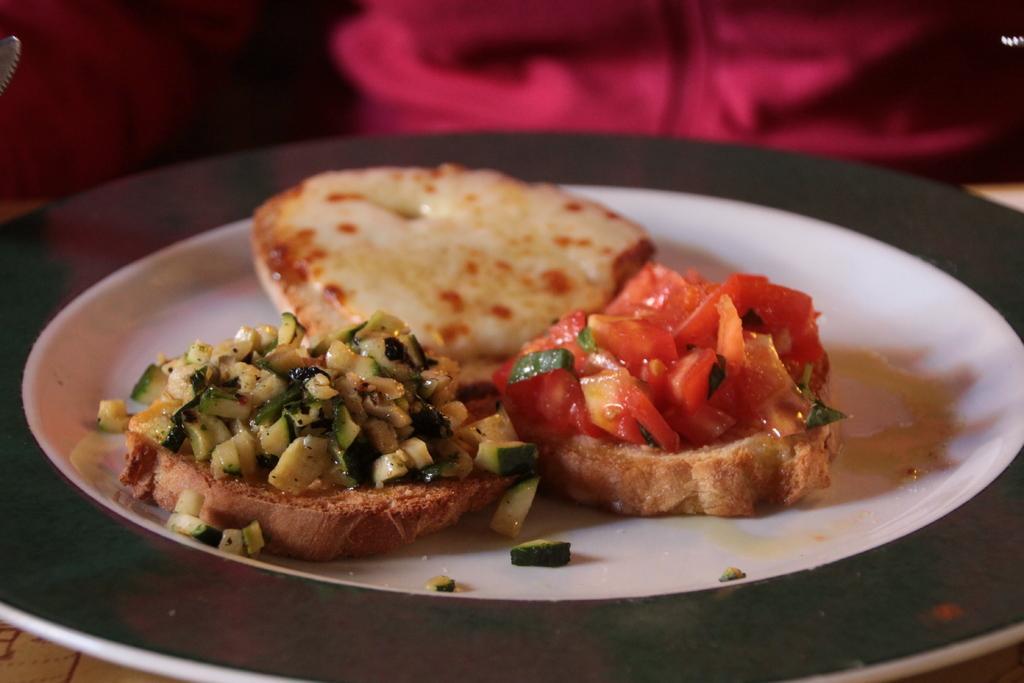Please provide a concise description of this image. In this image, I can see a food item on a plate, which is placed on a table. There is a blurred background. 